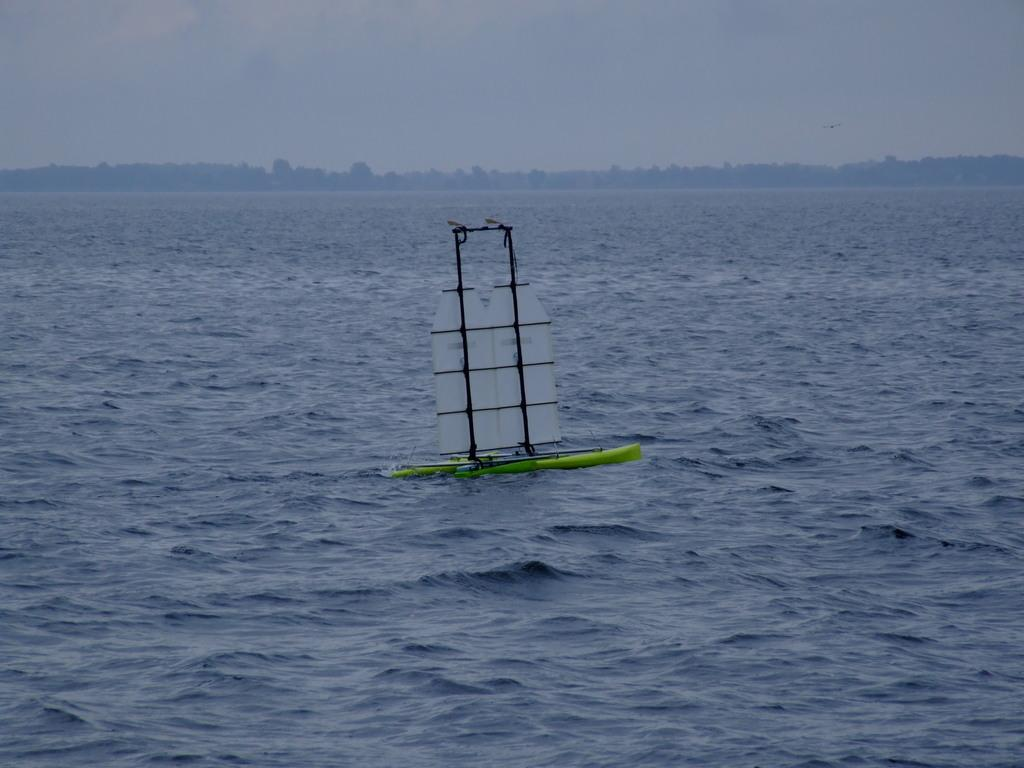What is the main subject of the image? The main subject of the image is a boat. Where is the boat located? The boat is on the water. What can be seen in the background of the image? There are trees and the sky visible in the background of the image. How many women are controlling the boat in the image? There is no mention of women or control in the image; it simply shows a boat on the water. 